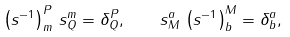Convert formula to latex. <formula><loc_0><loc_0><loc_500><loc_500>\left ( s ^ { - 1 } \right ) _ { m } ^ { P } \, s _ { Q } ^ { m } = \delta _ { Q } ^ { P } , \quad s _ { M } ^ { a } \, \left ( s ^ { - 1 } \right ) _ { b } ^ { M } = \delta _ { b } ^ { a } ,</formula> 